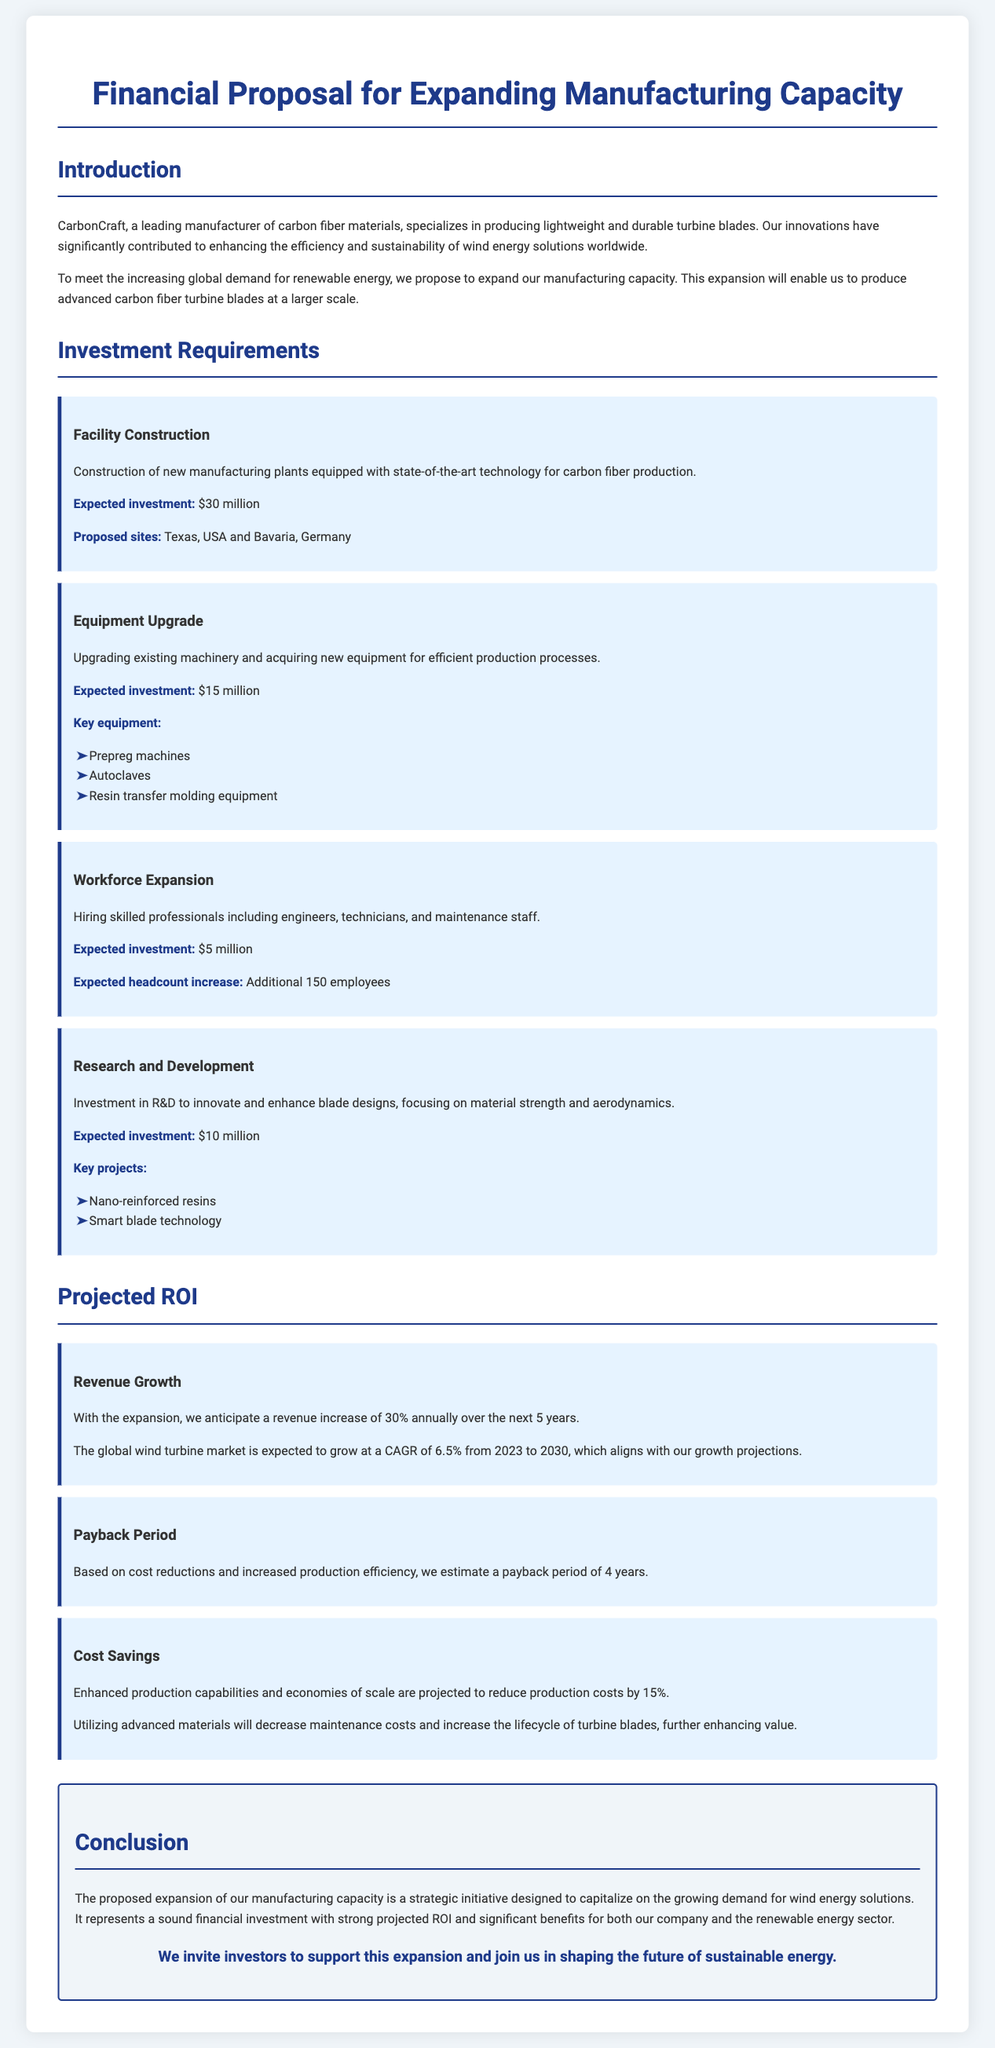What is the total expected investment for facility construction? The total expected investment for facility construction is specified as $30 million in the document.
Answer: $30 million What is the expected annual revenue increase after expansion? The expected annual revenue increase after expansion is stated as 30% annually over the next 5 years in the document.
Answer: 30% How many additional employees does the workforce expansion expect to hire? The expected headcount increase from workforce expansion is indicated as 150 employees in the document.
Answer: 150 employees What are the proposed sites for the new manufacturing plants? The proposed sites for the new manufacturing plants are outlined as Texas, USA and Bavaria, Germany in the document.
Answer: Texas, USA and Bavaria, Germany What is the estimated payback period for the investment? The estimated payback period for the investment is mentioned as 4 years in the document.
Answer: 4 years What is one of the key projects in the research and development section? A key project in the research and development section is identified as smart blade technology in the document.
Answer: Smart blade technology What percentage reduction in production costs is projected? The projected reduction in production costs is stated to be 15% in the document.
Answer: 15% What is the main purpose of the proposal? The main purpose of the proposal is to capitalize on the growing demand for wind energy solutions as stated in the conclusion of the document.
Answer: Capitalize on the growing demand for wind energy solutions 